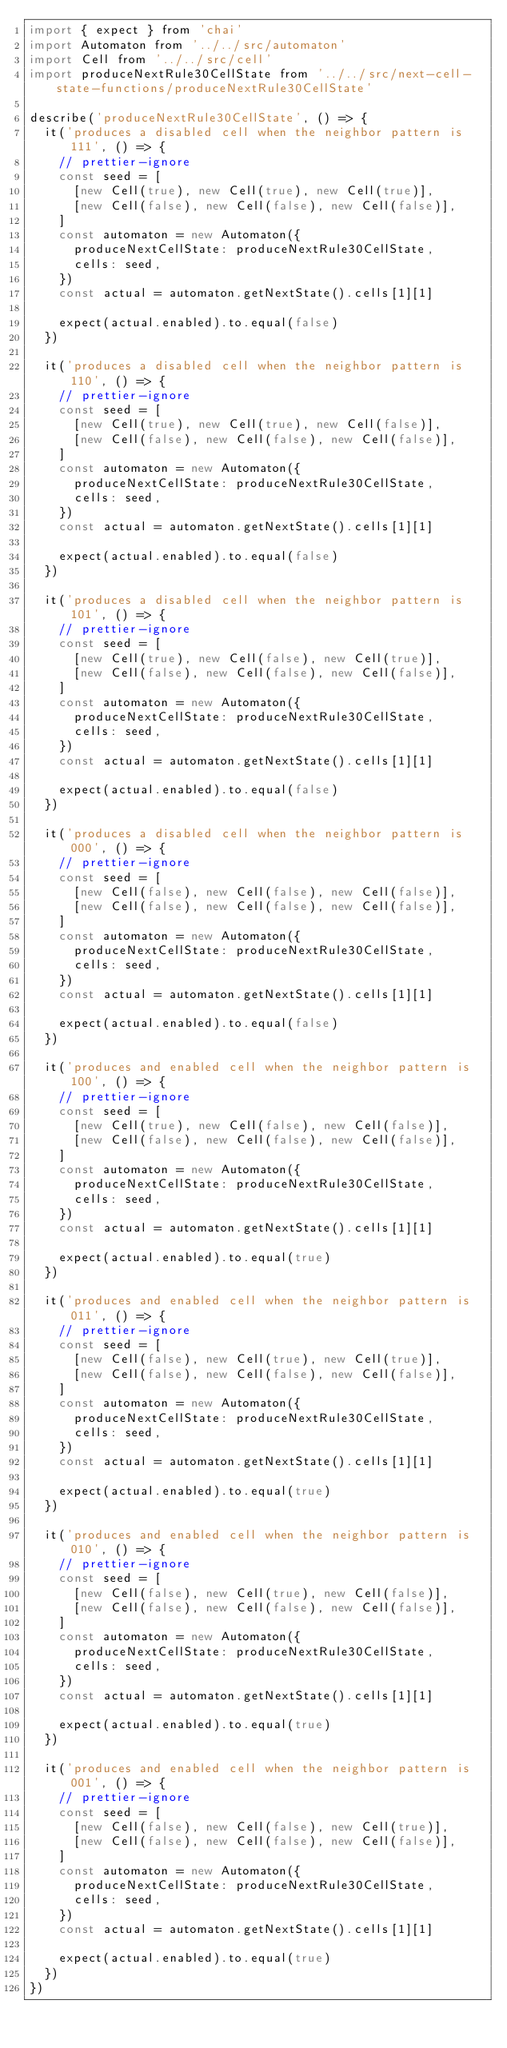<code> <loc_0><loc_0><loc_500><loc_500><_JavaScript_>import { expect } from 'chai'
import Automaton from '../../src/automaton'
import Cell from '../../src/cell'
import produceNextRule30CellState from '../../src/next-cell-state-functions/produceNextRule30CellState'

describe('produceNextRule30CellState', () => {
  it('produces a disabled cell when the neighbor pattern is 111', () => {
    // prettier-ignore
    const seed = [
      [new Cell(true), new Cell(true), new Cell(true)],
      [new Cell(false), new Cell(false), new Cell(false)],
    ]
    const automaton = new Automaton({
      produceNextCellState: produceNextRule30CellState,
      cells: seed,
    })
    const actual = automaton.getNextState().cells[1][1]

    expect(actual.enabled).to.equal(false)
  })

  it('produces a disabled cell when the neighbor pattern is 110', () => {
    // prettier-ignore
    const seed = [
      [new Cell(true), new Cell(true), new Cell(false)],
      [new Cell(false), new Cell(false), new Cell(false)],
    ]
    const automaton = new Automaton({
      produceNextCellState: produceNextRule30CellState,
      cells: seed,
    })
    const actual = automaton.getNextState().cells[1][1]

    expect(actual.enabled).to.equal(false)
  })

  it('produces a disabled cell when the neighbor pattern is 101', () => {
    // prettier-ignore
    const seed = [
      [new Cell(true), new Cell(false), new Cell(true)],
      [new Cell(false), new Cell(false), new Cell(false)],
    ]
    const automaton = new Automaton({
      produceNextCellState: produceNextRule30CellState,
      cells: seed,
    })
    const actual = automaton.getNextState().cells[1][1]

    expect(actual.enabled).to.equal(false)
  })

  it('produces a disabled cell when the neighbor pattern is 000', () => {
    // prettier-ignore
    const seed = [
      [new Cell(false), new Cell(false), new Cell(false)],
      [new Cell(false), new Cell(false), new Cell(false)],
    ]
    const automaton = new Automaton({
      produceNextCellState: produceNextRule30CellState,
      cells: seed,
    })
    const actual = automaton.getNextState().cells[1][1]

    expect(actual.enabled).to.equal(false)
  })

  it('produces and enabled cell when the neighbor pattern is 100', () => {
    // prettier-ignore
    const seed = [
      [new Cell(true), new Cell(false), new Cell(false)],
      [new Cell(false), new Cell(false), new Cell(false)],
    ]
    const automaton = new Automaton({
      produceNextCellState: produceNextRule30CellState,
      cells: seed,
    })
    const actual = automaton.getNextState().cells[1][1]

    expect(actual.enabled).to.equal(true)
  })

  it('produces and enabled cell when the neighbor pattern is 011', () => {
    // prettier-ignore
    const seed = [
      [new Cell(false), new Cell(true), new Cell(true)],
      [new Cell(false), new Cell(false), new Cell(false)],
    ]
    const automaton = new Automaton({
      produceNextCellState: produceNextRule30CellState,
      cells: seed,
    })
    const actual = automaton.getNextState().cells[1][1]

    expect(actual.enabled).to.equal(true)
  })

  it('produces and enabled cell when the neighbor pattern is 010', () => {
    // prettier-ignore
    const seed = [
      [new Cell(false), new Cell(true), new Cell(false)],
      [new Cell(false), new Cell(false), new Cell(false)],
    ]
    const automaton = new Automaton({
      produceNextCellState: produceNextRule30CellState,
      cells: seed,
    })
    const actual = automaton.getNextState().cells[1][1]

    expect(actual.enabled).to.equal(true)
  })

  it('produces and enabled cell when the neighbor pattern is 001', () => {
    // prettier-ignore
    const seed = [
      [new Cell(false), new Cell(false), new Cell(true)],
      [new Cell(false), new Cell(false), new Cell(false)],
    ]
    const automaton = new Automaton({
      produceNextCellState: produceNextRule30CellState,
      cells: seed,
    })
    const actual = automaton.getNextState().cells[1][1]

    expect(actual.enabled).to.equal(true)
  })
})
</code> 